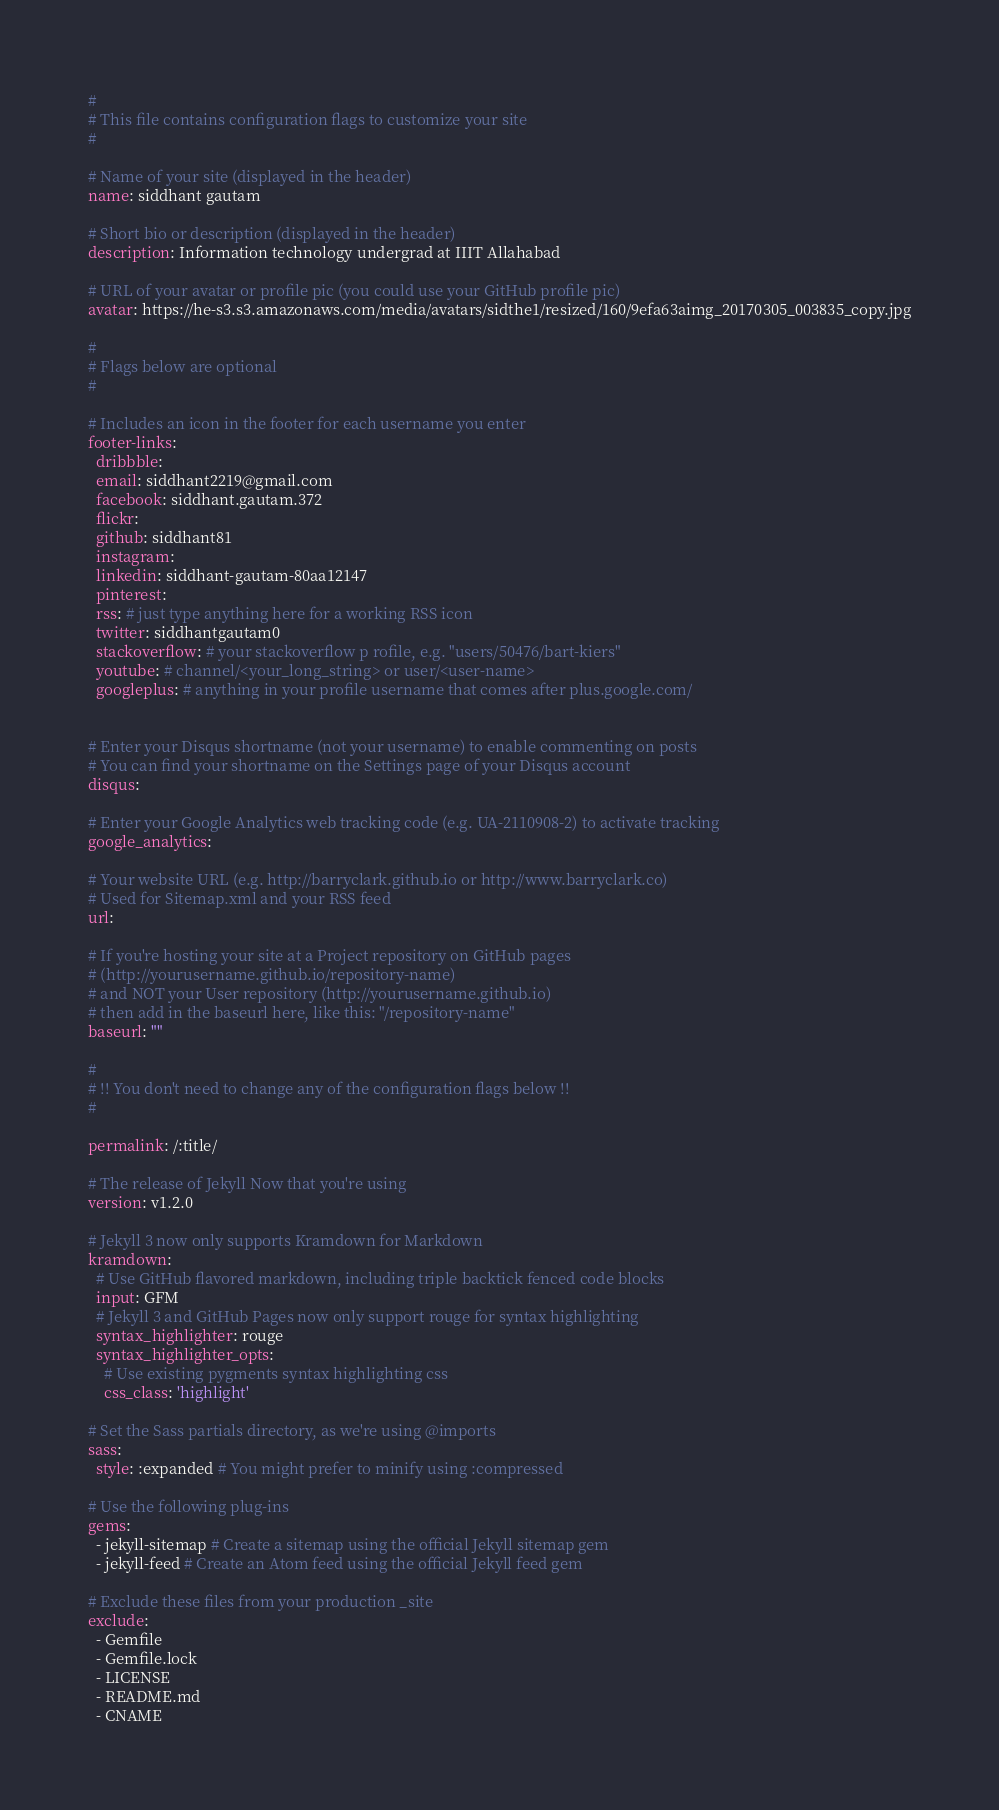Convert code to text. <code><loc_0><loc_0><loc_500><loc_500><_YAML_>#
# This file contains configuration flags to customize your site
#

# Name of your site (displayed in the header)
name: siddhant gautam

# Short bio or description (displayed in the header)
description: Information technology undergrad at IIIT Allahabad

# URL of your avatar or profile pic (you could use your GitHub profile pic)
avatar: https://he-s3.s3.amazonaws.com/media/avatars/sidthe1/resized/160/9efa63aimg_20170305_003835_copy.jpg

#
# Flags below are optional
#

# Includes an icon in the footer for each username you enter
footer-links:
  dribbble:
  email: siddhant2219@gmail.com
  facebook: siddhant.gautam.372
  flickr:
  github: siddhant81
  instagram:
  linkedin: siddhant-gautam-80aa12147
  pinterest:
  rss: # just type anything here for a working RSS icon
  twitter: siddhantgautam0
  stackoverflow: # your stackoverflow p rofile, e.g. "users/50476/bart-kiers"
  youtube: # channel/<your_long_string> or user/<user-name>
  googleplus: # anything in your profile username that comes after plus.google.com/


# Enter your Disqus shortname (not your username) to enable commenting on posts
# You can find your shortname on the Settings page of your Disqus account
disqus:

# Enter your Google Analytics web tracking code (e.g. UA-2110908-2) to activate tracking
google_analytics:

# Your website URL (e.g. http://barryclark.github.io or http://www.barryclark.co)
# Used for Sitemap.xml and your RSS feed
url:

# If you're hosting your site at a Project repository on GitHub pages
# (http://yourusername.github.io/repository-name)
# and NOT your User repository (http://yourusername.github.io)
# then add in the baseurl here, like this: "/repository-name"
baseurl: ""

#
# !! You don't need to change any of the configuration flags below !!
#

permalink: /:title/

# The release of Jekyll Now that you're using
version: v1.2.0

# Jekyll 3 now only supports Kramdown for Markdown
kramdown:
  # Use GitHub flavored markdown, including triple backtick fenced code blocks
  input: GFM
  # Jekyll 3 and GitHub Pages now only support rouge for syntax highlighting
  syntax_highlighter: rouge
  syntax_highlighter_opts:
    # Use existing pygments syntax highlighting css
    css_class: 'highlight'

# Set the Sass partials directory, as we're using @imports
sass:
  style: :expanded # You might prefer to minify using :compressed

# Use the following plug-ins
gems:
  - jekyll-sitemap # Create a sitemap using the official Jekyll sitemap gem
  - jekyll-feed # Create an Atom feed using the official Jekyll feed gem

# Exclude these files from your production _site
exclude:
  - Gemfile
  - Gemfile.lock
  - LICENSE
  - README.md
  - CNAME
</code> 